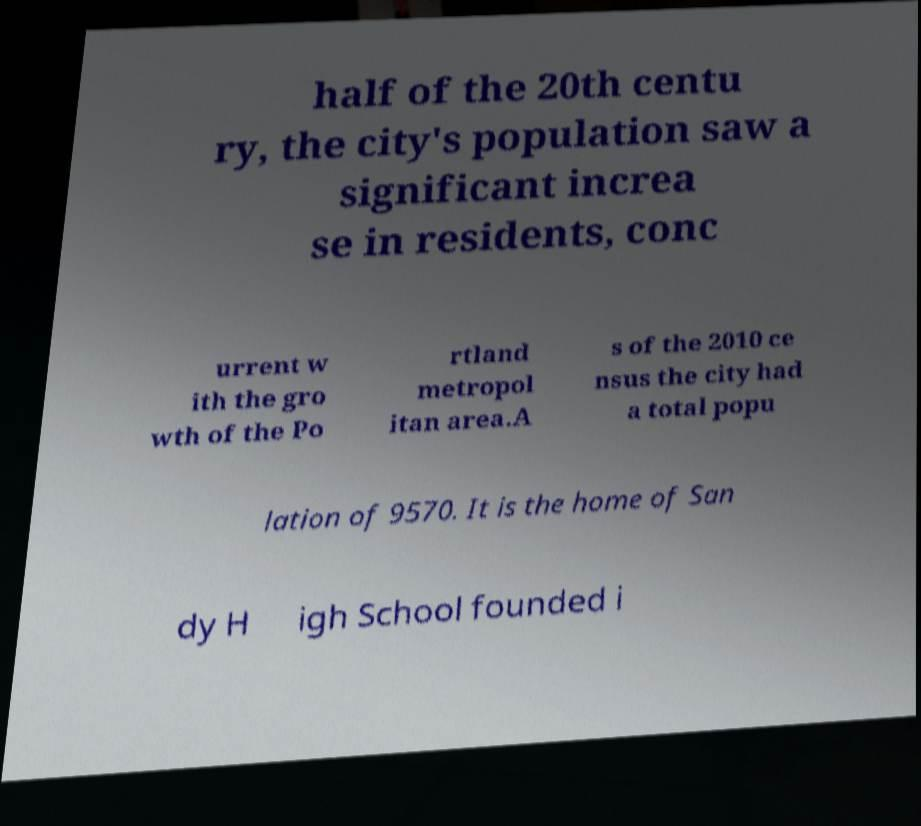Please read and relay the text visible in this image. What does it say? half of the 20th centu ry, the city's population saw a significant increa se in residents, conc urrent w ith the gro wth of the Po rtland metropol itan area.A s of the 2010 ce nsus the city had a total popu lation of 9570. It is the home of San dy H igh School founded i 